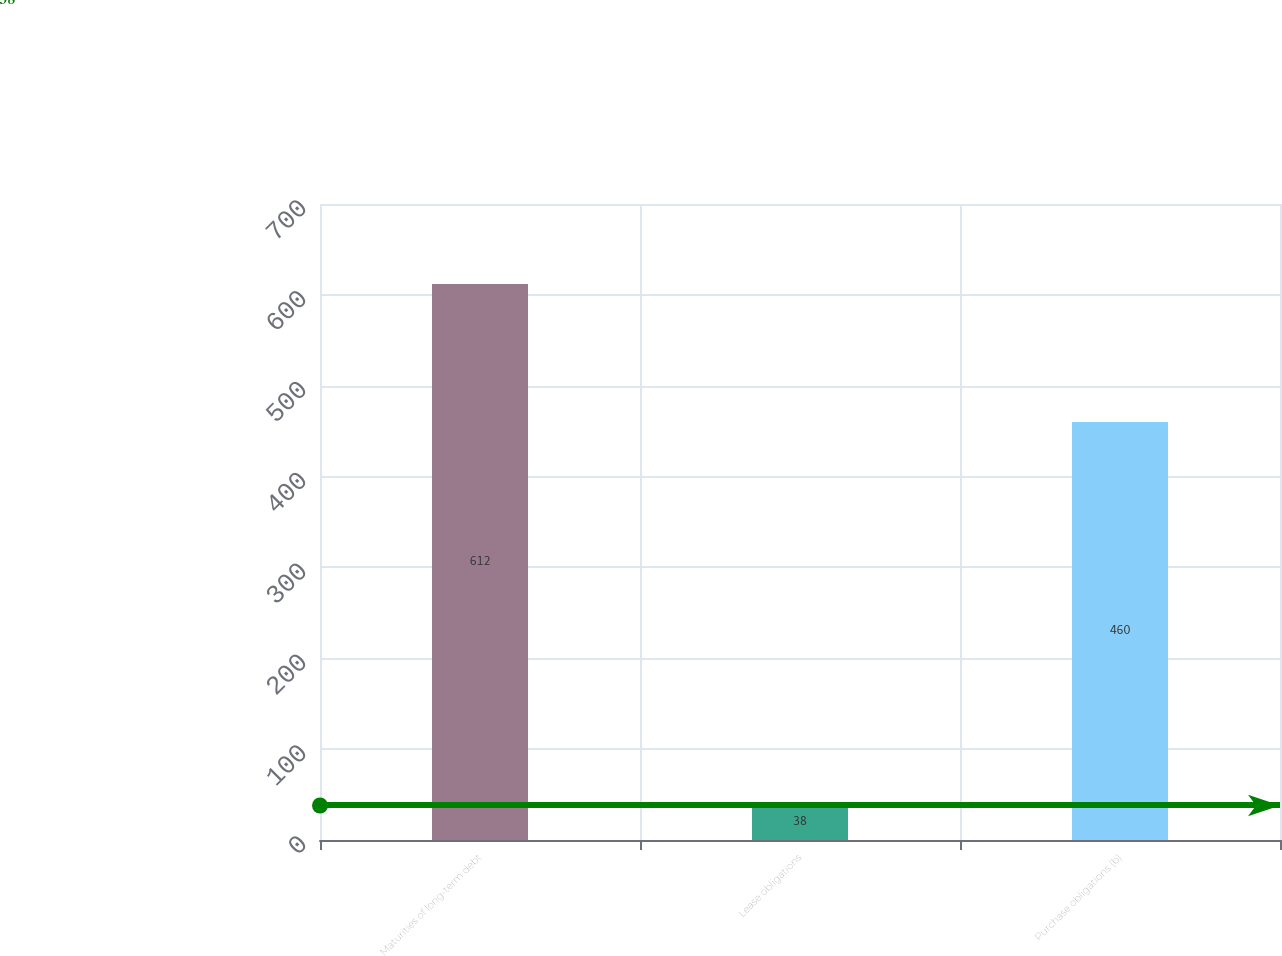<chart> <loc_0><loc_0><loc_500><loc_500><bar_chart><fcel>Maturities of long-term debt<fcel>Lease obligations<fcel>Purchase obligations (b)<nl><fcel>612<fcel>38<fcel>460<nl></chart> 